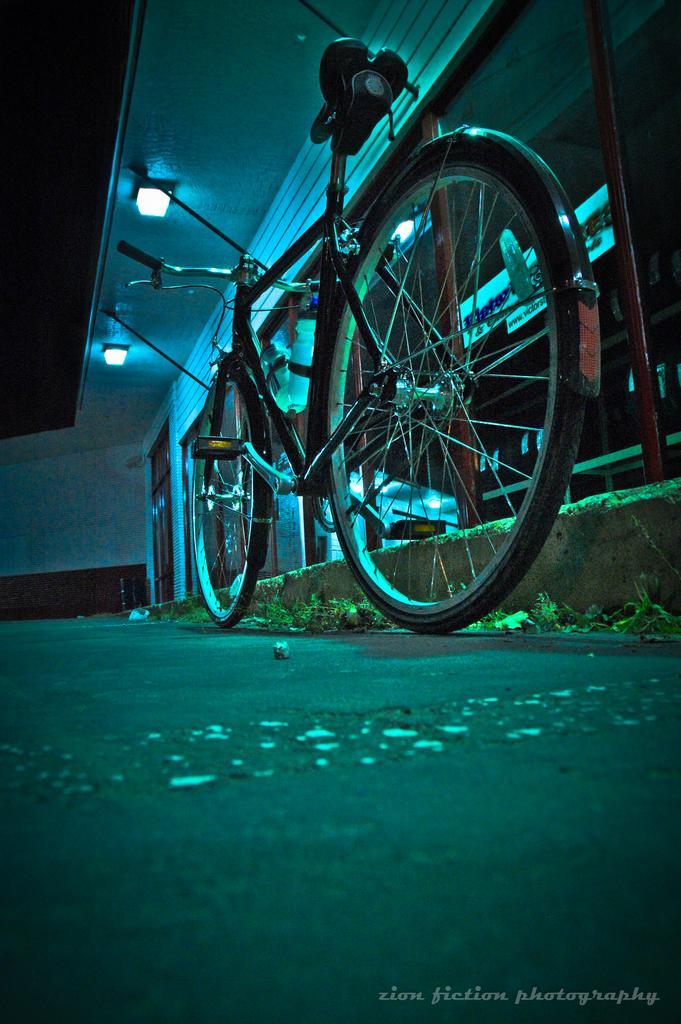Can you describe this image briefly? In the center of the image there is a cycle on the road. At the top of the image there is ceiling with lights. At the bottom of the image there is some text. 